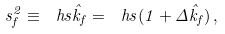<formula> <loc_0><loc_0><loc_500><loc_500>s _ { f } ^ { 2 } \equiv \ h s \hat { k } _ { f } = \ h s ( 1 + \Delta \hat { k } _ { f } ) \, ,</formula> 